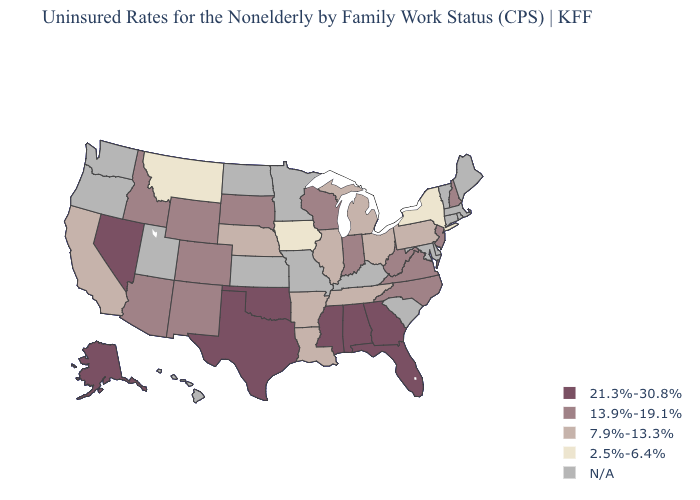Name the states that have a value in the range 13.9%-19.1%?
Answer briefly. Arizona, Colorado, Idaho, Indiana, New Hampshire, New Jersey, New Mexico, North Carolina, South Dakota, Virginia, West Virginia, Wisconsin, Wyoming. Does the first symbol in the legend represent the smallest category?
Give a very brief answer. No. What is the lowest value in the USA?
Write a very short answer. 2.5%-6.4%. What is the lowest value in the USA?
Answer briefly. 2.5%-6.4%. Which states have the lowest value in the MidWest?
Short answer required. Iowa. Among the states that border Nebraska , which have the highest value?
Keep it brief. Colorado, South Dakota, Wyoming. What is the value of West Virginia?
Answer briefly. 13.9%-19.1%. How many symbols are there in the legend?
Quick response, please. 5. Among the states that border Tennessee , which have the highest value?
Write a very short answer. Alabama, Georgia, Mississippi. Is the legend a continuous bar?
Give a very brief answer. No. Which states have the highest value in the USA?
Give a very brief answer. Alabama, Alaska, Florida, Georgia, Mississippi, Nevada, Oklahoma, Texas. Name the states that have a value in the range N/A?
Keep it brief. Connecticut, Delaware, Hawaii, Kansas, Kentucky, Maine, Maryland, Massachusetts, Minnesota, Missouri, North Dakota, Oregon, Rhode Island, South Carolina, Utah, Vermont, Washington. Among the states that border Kansas , does Colorado have the lowest value?
Quick response, please. No. 